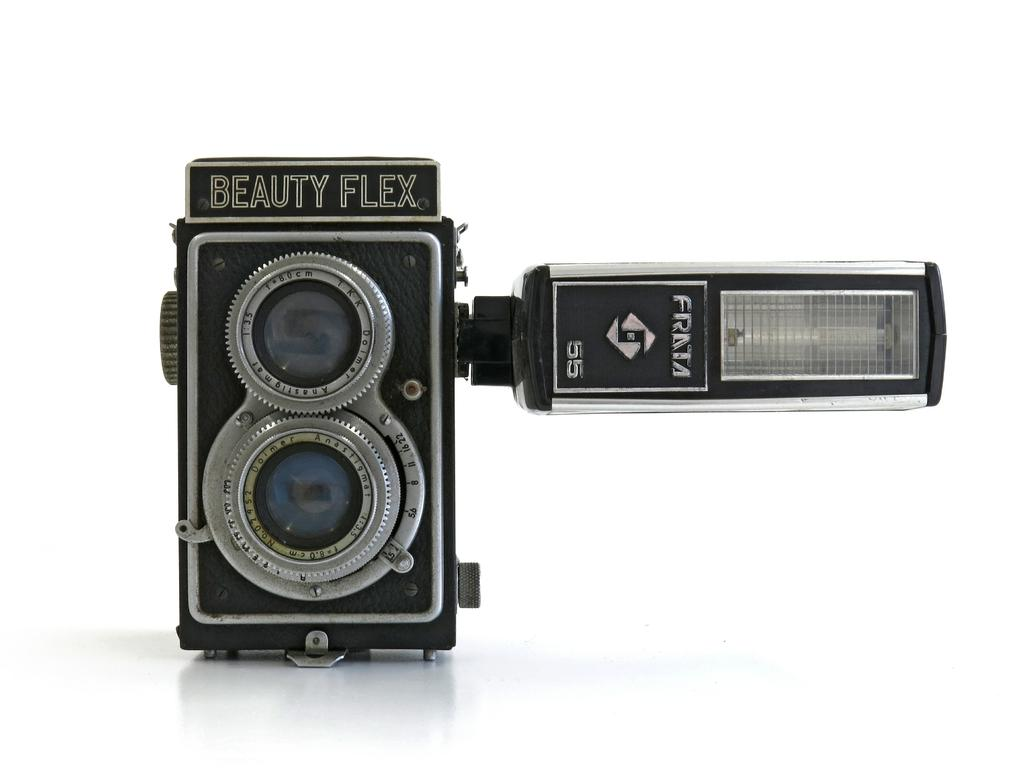<image>
Present a compact description of the photo's key features. A Beauty Flex camera with a Franta flash sits alone. 